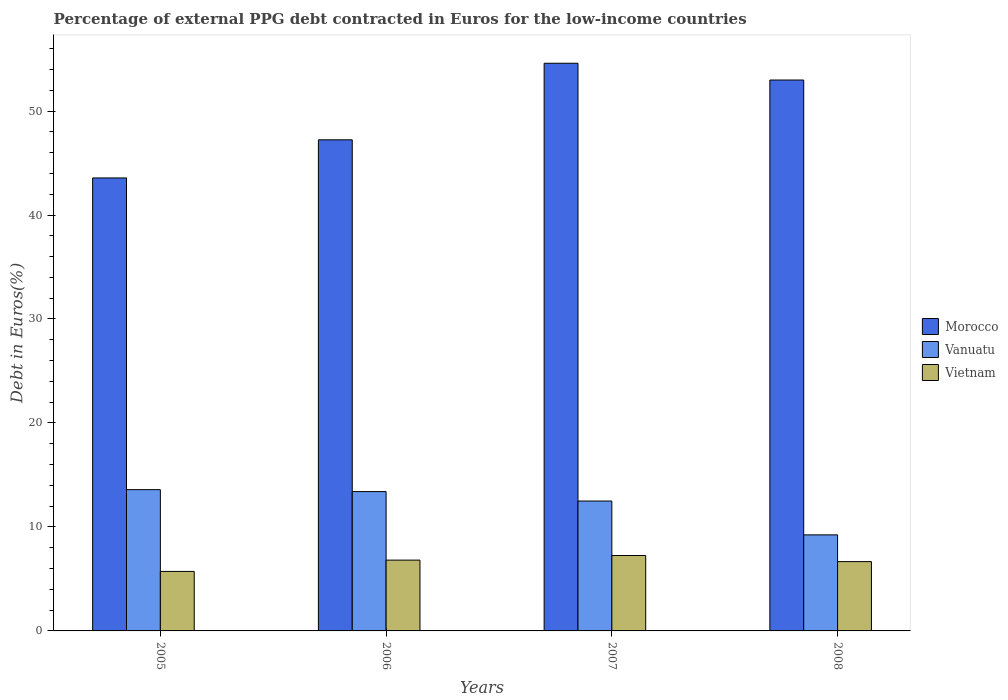Are the number of bars on each tick of the X-axis equal?
Offer a very short reply. Yes. How many bars are there on the 4th tick from the left?
Your answer should be very brief. 3. In how many cases, is the number of bars for a given year not equal to the number of legend labels?
Make the answer very short. 0. What is the percentage of external PPG debt contracted in Euros in Vanuatu in 2007?
Provide a short and direct response. 12.49. Across all years, what is the maximum percentage of external PPG debt contracted in Euros in Morocco?
Your response must be concise. 54.6. Across all years, what is the minimum percentage of external PPG debt contracted in Euros in Morocco?
Your response must be concise. 43.57. In which year was the percentage of external PPG debt contracted in Euros in Vietnam minimum?
Provide a succinct answer. 2005. What is the total percentage of external PPG debt contracted in Euros in Morocco in the graph?
Provide a succinct answer. 198.38. What is the difference between the percentage of external PPG debt contracted in Euros in Morocco in 2005 and that in 2006?
Your answer should be compact. -3.67. What is the difference between the percentage of external PPG debt contracted in Euros in Morocco in 2008 and the percentage of external PPG debt contracted in Euros in Vietnam in 2005?
Provide a short and direct response. 47.26. What is the average percentage of external PPG debt contracted in Euros in Vietnam per year?
Offer a terse response. 6.61. In the year 2005, what is the difference between the percentage of external PPG debt contracted in Euros in Vietnam and percentage of external PPG debt contracted in Euros in Vanuatu?
Offer a terse response. -7.86. What is the ratio of the percentage of external PPG debt contracted in Euros in Vietnam in 2005 to that in 2008?
Provide a succinct answer. 0.86. Is the percentage of external PPG debt contracted in Euros in Vietnam in 2007 less than that in 2008?
Your response must be concise. No. Is the difference between the percentage of external PPG debt contracted in Euros in Vietnam in 2006 and 2008 greater than the difference between the percentage of external PPG debt contracted in Euros in Vanuatu in 2006 and 2008?
Provide a short and direct response. No. What is the difference between the highest and the second highest percentage of external PPG debt contracted in Euros in Morocco?
Keep it short and to the point. 1.61. What is the difference between the highest and the lowest percentage of external PPG debt contracted in Euros in Vietnam?
Provide a succinct answer. 1.53. In how many years, is the percentage of external PPG debt contracted in Euros in Vanuatu greater than the average percentage of external PPG debt contracted in Euros in Vanuatu taken over all years?
Offer a very short reply. 3. What does the 1st bar from the left in 2008 represents?
Make the answer very short. Morocco. What does the 2nd bar from the right in 2008 represents?
Ensure brevity in your answer.  Vanuatu. Is it the case that in every year, the sum of the percentage of external PPG debt contracted in Euros in Morocco and percentage of external PPG debt contracted in Euros in Vietnam is greater than the percentage of external PPG debt contracted in Euros in Vanuatu?
Your answer should be very brief. Yes. How many bars are there?
Make the answer very short. 12. How many years are there in the graph?
Provide a succinct answer. 4. What is the difference between two consecutive major ticks on the Y-axis?
Give a very brief answer. 10. Does the graph contain grids?
Your answer should be compact. No. Where does the legend appear in the graph?
Make the answer very short. Center right. How many legend labels are there?
Your answer should be very brief. 3. What is the title of the graph?
Give a very brief answer. Percentage of external PPG debt contracted in Euros for the low-income countries. What is the label or title of the X-axis?
Give a very brief answer. Years. What is the label or title of the Y-axis?
Give a very brief answer. Debt in Euros(%). What is the Debt in Euros(%) of Morocco in 2005?
Provide a short and direct response. 43.57. What is the Debt in Euros(%) in Vanuatu in 2005?
Provide a succinct answer. 13.59. What is the Debt in Euros(%) in Vietnam in 2005?
Your answer should be very brief. 5.72. What is the Debt in Euros(%) of Morocco in 2006?
Provide a succinct answer. 47.23. What is the Debt in Euros(%) in Vanuatu in 2006?
Offer a terse response. 13.4. What is the Debt in Euros(%) in Vietnam in 2006?
Offer a terse response. 6.81. What is the Debt in Euros(%) of Morocco in 2007?
Make the answer very short. 54.6. What is the Debt in Euros(%) of Vanuatu in 2007?
Your answer should be very brief. 12.49. What is the Debt in Euros(%) in Vietnam in 2007?
Provide a succinct answer. 7.25. What is the Debt in Euros(%) in Morocco in 2008?
Offer a terse response. 52.98. What is the Debt in Euros(%) in Vanuatu in 2008?
Provide a short and direct response. 9.24. What is the Debt in Euros(%) of Vietnam in 2008?
Provide a short and direct response. 6.67. Across all years, what is the maximum Debt in Euros(%) in Morocco?
Ensure brevity in your answer.  54.6. Across all years, what is the maximum Debt in Euros(%) of Vanuatu?
Give a very brief answer. 13.59. Across all years, what is the maximum Debt in Euros(%) in Vietnam?
Your answer should be compact. 7.25. Across all years, what is the minimum Debt in Euros(%) in Morocco?
Keep it short and to the point. 43.57. Across all years, what is the minimum Debt in Euros(%) of Vanuatu?
Offer a very short reply. 9.24. Across all years, what is the minimum Debt in Euros(%) in Vietnam?
Provide a short and direct response. 5.72. What is the total Debt in Euros(%) in Morocco in the graph?
Provide a short and direct response. 198.38. What is the total Debt in Euros(%) of Vanuatu in the graph?
Make the answer very short. 48.72. What is the total Debt in Euros(%) of Vietnam in the graph?
Offer a terse response. 26.45. What is the difference between the Debt in Euros(%) in Morocco in 2005 and that in 2006?
Ensure brevity in your answer.  -3.67. What is the difference between the Debt in Euros(%) in Vanuatu in 2005 and that in 2006?
Give a very brief answer. 0.19. What is the difference between the Debt in Euros(%) in Vietnam in 2005 and that in 2006?
Provide a succinct answer. -1.09. What is the difference between the Debt in Euros(%) of Morocco in 2005 and that in 2007?
Provide a short and direct response. -11.03. What is the difference between the Debt in Euros(%) of Vanuatu in 2005 and that in 2007?
Give a very brief answer. 1.09. What is the difference between the Debt in Euros(%) in Vietnam in 2005 and that in 2007?
Offer a very short reply. -1.53. What is the difference between the Debt in Euros(%) in Morocco in 2005 and that in 2008?
Provide a succinct answer. -9.42. What is the difference between the Debt in Euros(%) in Vanuatu in 2005 and that in 2008?
Provide a succinct answer. 4.35. What is the difference between the Debt in Euros(%) in Vietnam in 2005 and that in 2008?
Offer a very short reply. -0.94. What is the difference between the Debt in Euros(%) of Morocco in 2006 and that in 2007?
Provide a succinct answer. -7.36. What is the difference between the Debt in Euros(%) in Vanuatu in 2006 and that in 2007?
Provide a succinct answer. 0.91. What is the difference between the Debt in Euros(%) of Vietnam in 2006 and that in 2007?
Ensure brevity in your answer.  -0.44. What is the difference between the Debt in Euros(%) of Morocco in 2006 and that in 2008?
Provide a succinct answer. -5.75. What is the difference between the Debt in Euros(%) of Vanuatu in 2006 and that in 2008?
Your answer should be compact. 4.16. What is the difference between the Debt in Euros(%) in Vietnam in 2006 and that in 2008?
Your answer should be compact. 0.14. What is the difference between the Debt in Euros(%) in Morocco in 2007 and that in 2008?
Make the answer very short. 1.61. What is the difference between the Debt in Euros(%) of Vanuatu in 2007 and that in 2008?
Provide a succinct answer. 3.25. What is the difference between the Debt in Euros(%) in Vietnam in 2007 and that in 2008?
Ensure brevity in your answer.  0.59. What is the difference between the Debt in Euros(%) of Morocco in 2005 and the Debt in Euros(%) of Vanuatu in 2006?
Give a very brief answer. 30.17. What is the difference between the Debt in Euros(%) in Morocco in 2005 and the Debt in Euros(%) in Vietnam in 2006?
Make the answer very short. 36.76. What is the difference between the Debt in Euros(%) of Vanuatu in 2005 and the Debt in Euros(%) of Vietnam in 2006?
Your answer should be very brief. 6.78. What is the difference between the Debt in Euros(%) of Morocco in 2005 and the Debt in Euros(%) of Vanuatu in 2007?
Keep it short and to the point. 31.07. What is the difference between the Debt in Euros(%) of Morocco in 2005 and the Debt in Euros(%) of Vietnam in 2007?
Provide a succinct answer. 36.31. What is the difference between the Debt in Euros(%) of Vanuatu in 2005 and the Debt in Euros(%) of Vietnam in 2007?
Offer a very short reply. 6.33. What is the difference between the Debt in Euros(%) of Morocco in 2005 and the Debt in Euros(%) of Vanuatu in 2008?
Make the answer very short. 34.33. What is the difference between the Debt in Euros(%) in Morocco in 2005 and the Debt in Euros(%) in Vietnam in 2008?
Make the answer very short. 36.9. What is the difference between the Debt in Euros(%) in Vanuatu in 2005 and the Debt in Euros(%) in Vietnam in 2008?
Offer a terse response. 6.92. What is the difference between the Debt in Euros(%) in Morocco in 2006 and the Debt in Euros(%) in Vanuatu in 2007?
Ensure brevity in your answer.  34.74. What is the difference between the Debt in Euros(%) in Morocco in 2006 and the Debt in Euros(%) in Vietnam in 2007?
Offer a very short reply. 39.98. What is the difference between the Debt in Euros(%) of Vanuatu in 2006 and the Debt in Euros(%) of Vietnam in 2007?
Keep it short and to the point. 6.15. What is the difference between the Debt in Euros(%) of Morocco in 2006 and the Debt in Euros(%) of Vanuatu in 2008?
Ensure brevity in your answer.  37.99. What is the difference between the Debt in Euros(%) of Morocco in 2006 and the Debt in Euros(%) of Vietnam in 2008?
Make the answer very short. 40.57. What is the difference between the Debt in Euros(%) of Vanuatu in 2006 and the Debt in Euros(%) of Vietnam in 2008?
Your answer should be compact. 6.73. What is the difference between the Debt in Euros(%) of Morocco in 2007 and the Debt in Euros(%) of Vanuatu in 2008?
Offer a terse response. 45.36. What is the difference between the Debt in Euros(%) of Morocco in 2007 and the Debt in Euros(%) of Vietnam in 2008?
Give a very brief answer. 47.93. What is the difference between the Debt in Euros(%) of Vanuatu in 2007 and the Debt in Euros(%) of Vietnam in 2008?
Provide a succinct answer. 5.83. What is the average Debt in Euros(%) of Morocco per year?
Your response must be concise. 49.59. What is the average Debt in Euros(%) in Vanuatu per year?
Give a very brief answer. 12.18. What is the average Debt in Euros(%) in Vietnam per year?
Offer a terse response. 6.61. In the year 2005, what is the difference between the Debt in Euros(%) of Morocco and Debt in Euros(%) of Vanuatu?
Offer a very short reply. 29.98. In the year 2005, what is the difference between the Debt in Euros(%) in Morocco and Debt in Euros(%) in Vietnam?
Give a very brief answer. 37.84. In the year 2005, what is the difference between the Debt in Euros(%) in Vanuatu and Debt in Euros(%) in Vietnam?
Make the answer very short. 7.86. In the year 2006, what is the difference between the Debt in Euros(%) of Morocco and Debt in Euros(%) of Vanuatu?
Offer a terse response. 33.83. In the year 2006, what is the difference between the Debt in Euros(%) in Morocco and Debt in Euros(%) in Vietnam?
Make the answer very short. 40.42. In the year 2006, what is the difference between the Debt in Euros(%) in Vanuatu and Debt in Euros(%) in Vietnam?
Keep it short and to the point. 6.59. In the year 2007, what is the difference between the Debt in Euros(%) of Morocco and Debt in Euros(%) of Vanuatu?
Offer a terse response. 42.1. In the year 2007, what is the difference between the Debt in Euros(%) of Morocco and Debt in Euros(%) of Vietnam?
Give a very brief answer. 47.34. In the year 2007, what is the difference between the Debt in Euros(%) of Vanuatu and Debt in Euros(%) of Vietnam?
Keep it short and to the point. 5.24. In the year 2008, what is the difference between the Debt in Euros(%) in Morocco and Debt in Euros(%) in Vanuatu?
Provide a succinct answer. 43.75. In the year 2008, what is the difference between the Debt in Euros(%) in Morocco and Debt in Euros(%) in Vietnam?
Keep it short and to the point. 46.32. In the year 2008, what is the difference between the Debt in Euros(%) of Vanuatu and Debt in Euros(%) of Vietnam?
Your answer should be compact. 2.57. What is the ratio of the Debt in Euros(%) of Morocco in 2005 to that in 2006?
Provide a succinct answer. 0.92. What is the ratio of the Debt in Euros(%) in Vanuatu in 2005 to that in 2006?
Keep it short and to the point. 1.01. What is the ratio of the Debt in Euros(%) of Vietnam in 2005 to that in 2006?
Provide a short and direct response. 0.84. What is the ratio of the Debt in Euros(%) of Morocco in 2005 to that in 2007?
Ensure brevity in your answer.  0.8. What is the ratio of the Debt in Euros(%) of Vanuatu in 2005 to that in 2007?
Offer a terse response. 1.09. What is the ratio of the Debt in Euros(%) in Vietnam in 2005 to that in 2007?
Ensure brevity in your answer.  0.79. What is the ratio of the Debt in Euros(%) in Morocco in 2005 to that in 2008?
Offer a very short reply. 0.82. What is the ratio of the Debt in Euros(%) of Vanuatu in 2005 to that in 2008?
Keep it short and to the point. 1.47. What is the ratio of the Debt in Euros(%) of Vietnam in 2005 to that in 2008?
Provide a succinct answer. 0.86. What is the ratio of the Debt in Euros(%) in Morocco in 2006 to that in 2007?
Your response must be concise. 0.87. What is the ratio of the Debt in Euros(%) in Vanuatu in 2006 to that in 2007?
Your answer should be very brief. 1.07. What is the ratio of the Debt in Euros(%) in Vietnam in 2006 to that in 2007?
Provide a short and direct response. 0.94. What is the ratio of the Debt in Euros(%) in Morocco in 2006 to that in 2008?
Provide a succinct answer. 0.89. What is the ratio of the Debt in Euros(%) of Vanuatu in 2006 to that in 2008?
Your response must be concise. 1.45. What is the ratio of the Debt in Euros(%) of Vietnam in 2006 to that in 2008?
Provide a short and direct response. 1.02. What is the ratio of the Debt in Euros(%) of Morocco in 2007 to that in 2008?
Give a very brief answer. 1.03. What is the ratio of the Debt in Euros(%) in Vanuatu in 2007 to that in 2008?
Give a very brief answer. 1.35. What is the ratio of the Debt in Euros(%) in Vietnam in 2007 to that in 2008?
Keep it short and to the point. 1.09. What is the difference between the highest and the second highest Debt in Euros(%) of Morocco?
Ensure brevity in your answer.  1.61. What is the difference between the highest and the second highest Debt in Euros(%) of Vanuatu?
Give a very brief answer. 0.19. What is the difference between the highest and the second highest Debt in Euros(%) in Vietnam?
Your answer should be very brief. 0.44. What is the difference between the highest and the lowest Debt in Euros(%) of Morocco?
Offer a very short reply. 11.03. What is the difference between the highest and the lowest Debt in Euros(%) in Vanuatu?
Your answer should be very brief. 4.35. What is the difference between the highest and the lowest Debt in Euros(%) in Vietnam?
Your answer should be compact. 1.53. 